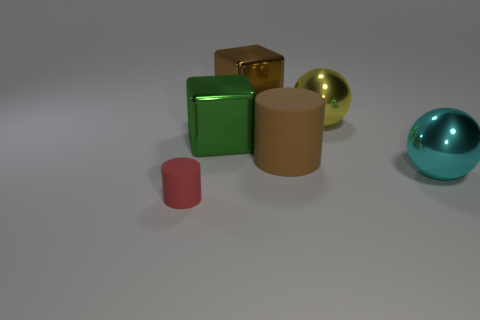Does the cylinder in front of the large brown matte cylinder have the same material as the cylinder behind the large cyan shiny object?
Offer a terse response. Yes. How many things are on the left side of the big matte cylinder and behind the red object?
Make the answer very short. 2. Is there another big metal object of the same shape as the large brown metallic object?
Your answer should be compact. Yes. The green object that is the same size as the yellow metal object is what shape?
Offer a very short reply. Cube. Is the number of small cylinders on the right side of the tiny red matte cylinder the same as the number of red rubber objects left of the big green block?
Provide a short and direct response. No. There is a metallic sphere in front of the sphere that is behind the large cyan sphere; how big is it?
Your response must be concise. Large. Are there any yellow shiny spheres of the same size as the yellow object?
Provide a succinct answer. No. The other block that is made of the same material as the brown block is what color?
Keep it short and to the point. Green. Are there fewer big brown objects than metal objects?
Provide a succinct answer. Yes. There is a thing that is both in front of the big brown cylinder and to the left of the big matte cylinder; what is its material?
Provide a succinct answer. Rubber. 